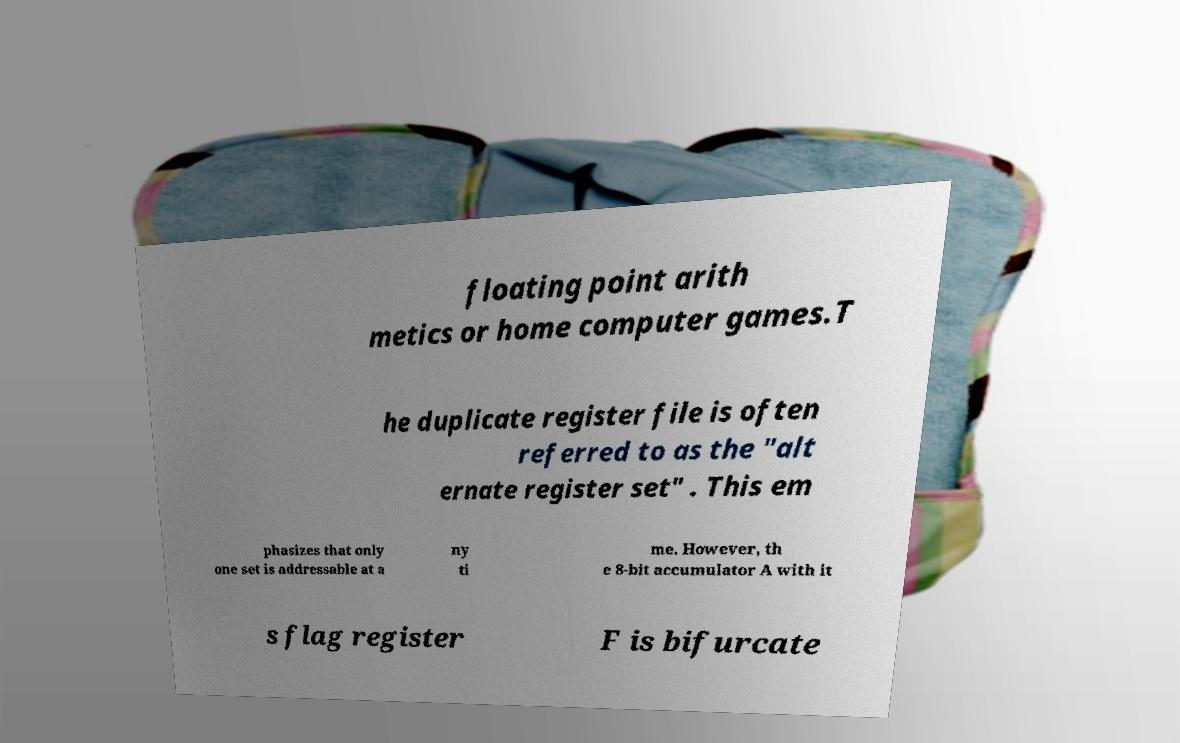Please identify and transcribe the text found in this image. floating point arith metics or home computer games.T he duplicate register file is often referred to as the "alt ernate register set" . This em phasizes that only one set is addressable at a ny ti me. However, th e 8-bit accumulator A with it s flag register F is bifurcate 